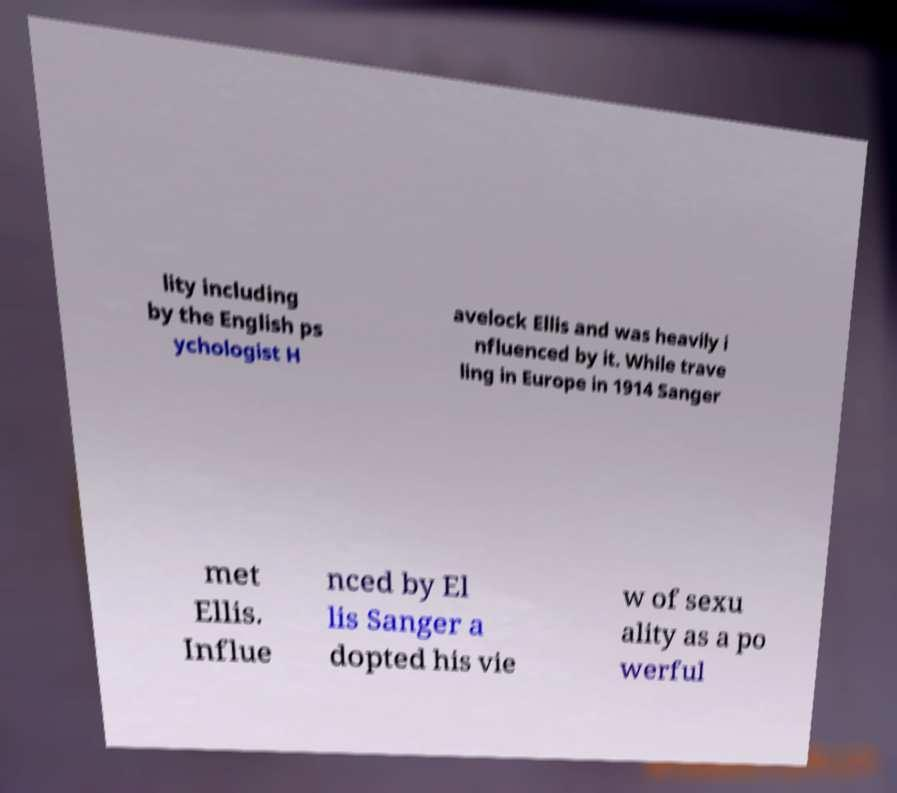Please read and relay the text visible in this image. What does it say? lity including by the English ps ychologist H avelock Ellis and was heavily i nfluenced by it. While trave ling in Europe in 1914 Sanger met Ellis. Influe nced by El lis Sanger a dopted his vie w of sexu ality as a po werful 